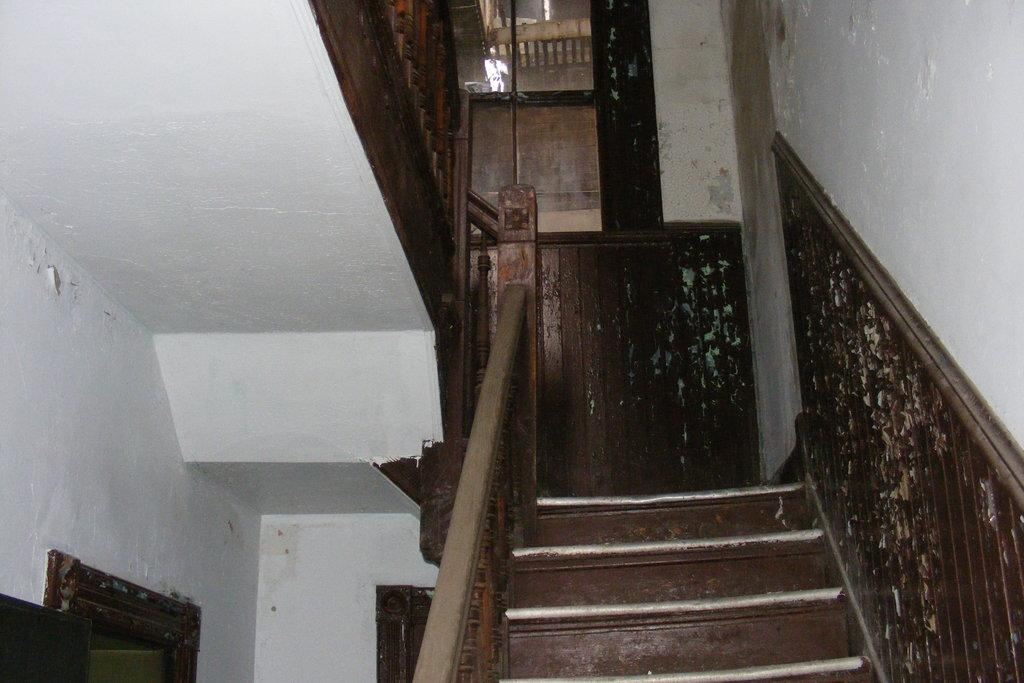What type of architectural feature is present in the image? There are stairs in the image. What safety feature is associated with the stairs? There is a railing associated with the stairs. What else can be seen in the image besides the stairs and railing? There is a wall visible in the image. What type of quartz can be seen on the base of the stairs in the image? There is no quartz present in the image, and the base of the stairs is not mentioned in the provided facts. 